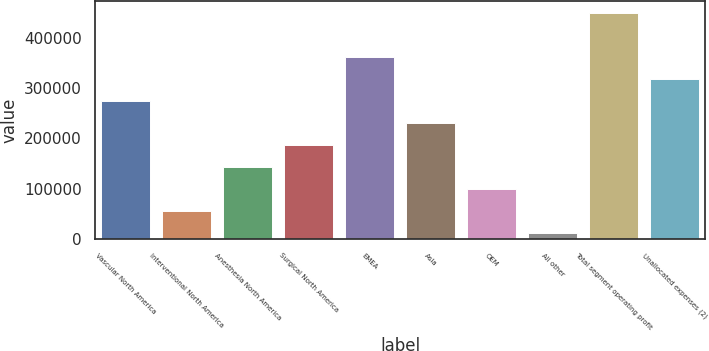Convert chart. <chart><loc_0><loc_0><loc_500><loc_500><bar_chart><fcel>Vascular North America<fcel>Interventional North America<fcel>Anesthesia North America<fcel>Surgical North America<fcel>EMEA<fcel>Asia<fcel>OEM<fcel>All other<fcel>Total segment operating profit<fcel>Unallocated expenses (2)<nl><fcel>274833<fcel>55090.5<fcel>142988<fcel>186936<fcel>362730<fcel>230884<fcel>99039<fcel>11142<fcel>450627<fcel>318782<nl></chart> 